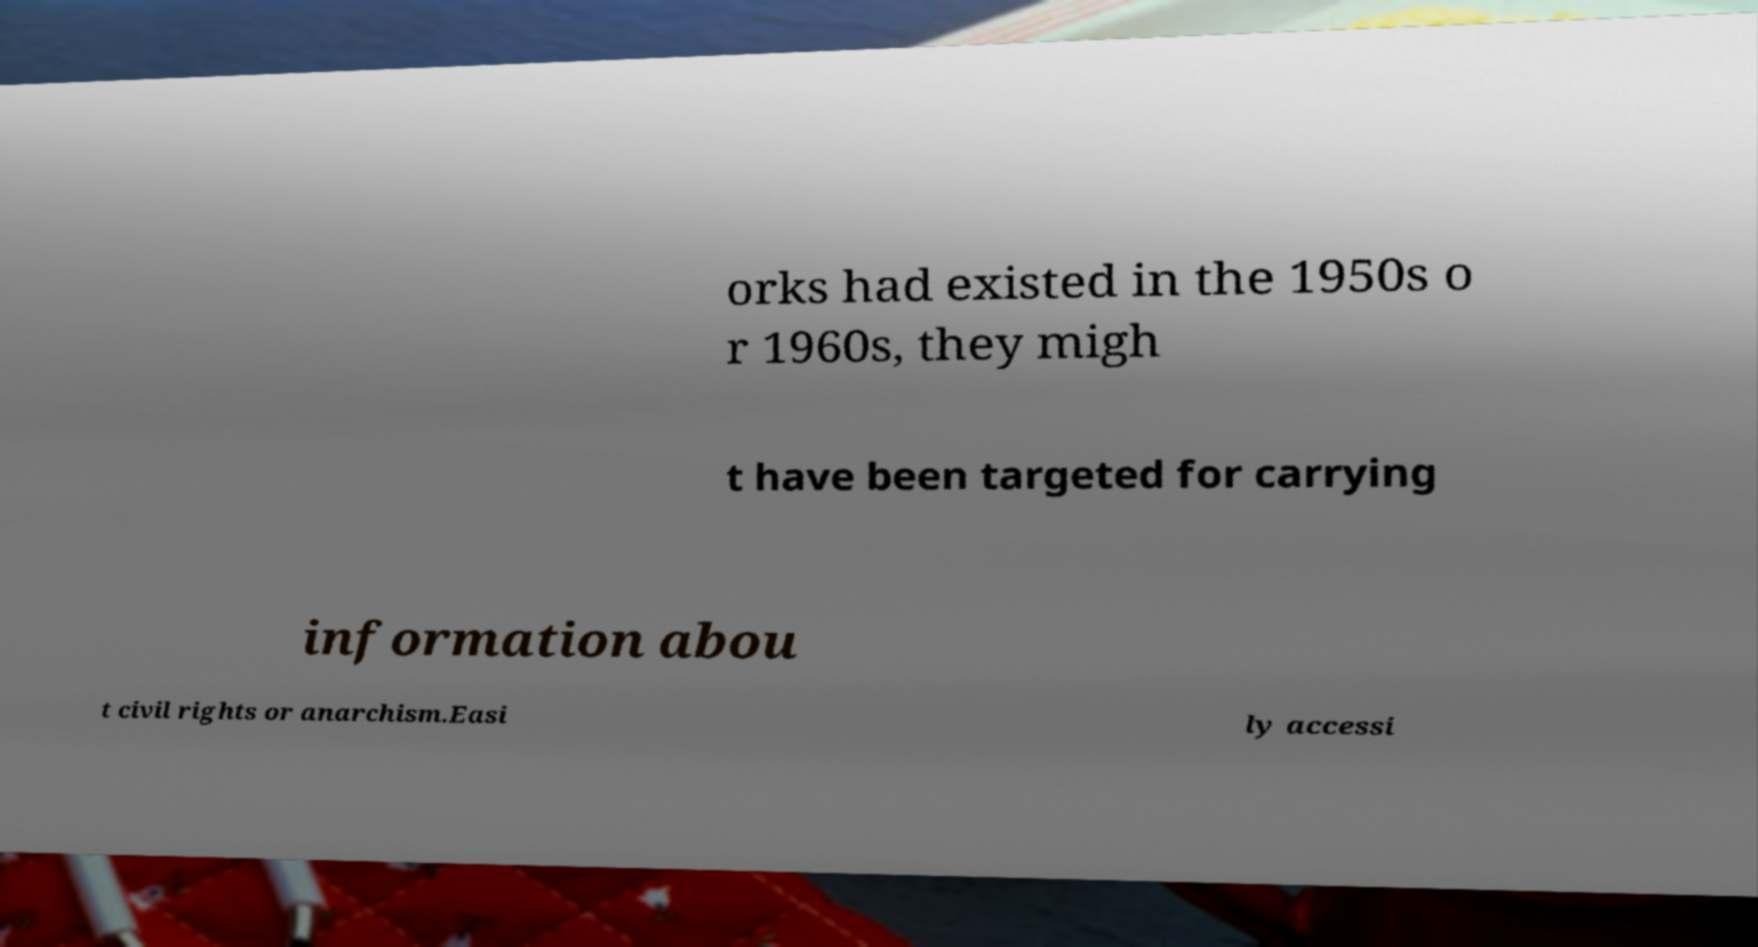Please identify and transcribe the text found in this image. orks had existed in the 1950s o r 1960s, they migh t have been targeted for carrying information abou t civil rights or anarchism.Easi ly accessi 